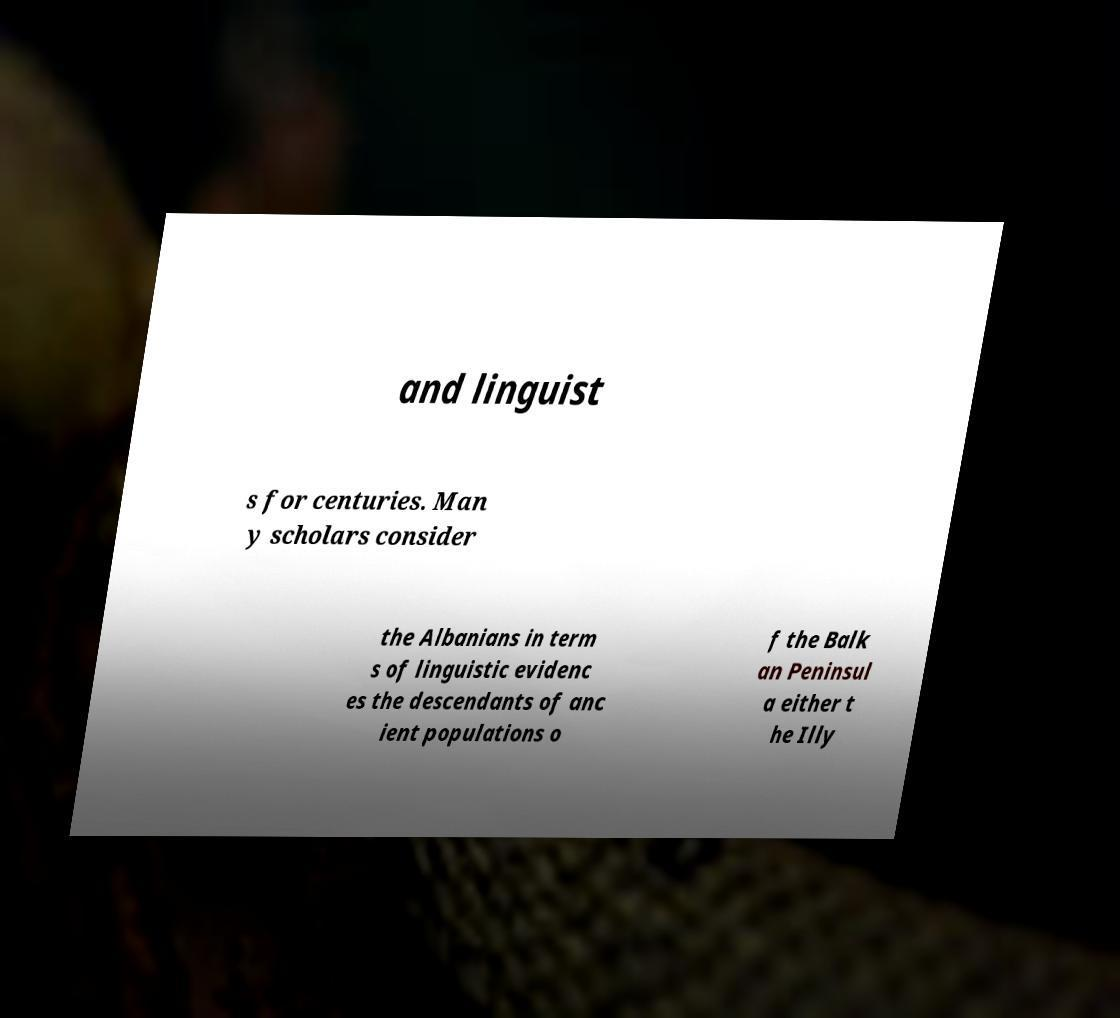There's text embedded in this image that I need extracted. Can you transcribe it verbatim? and linguist s for centuries. Man y scholars consider the Albanians in term s of linguistic evidenc es the descendants of anc ient populations o f the Balk an Peninsul a either t he Illy 